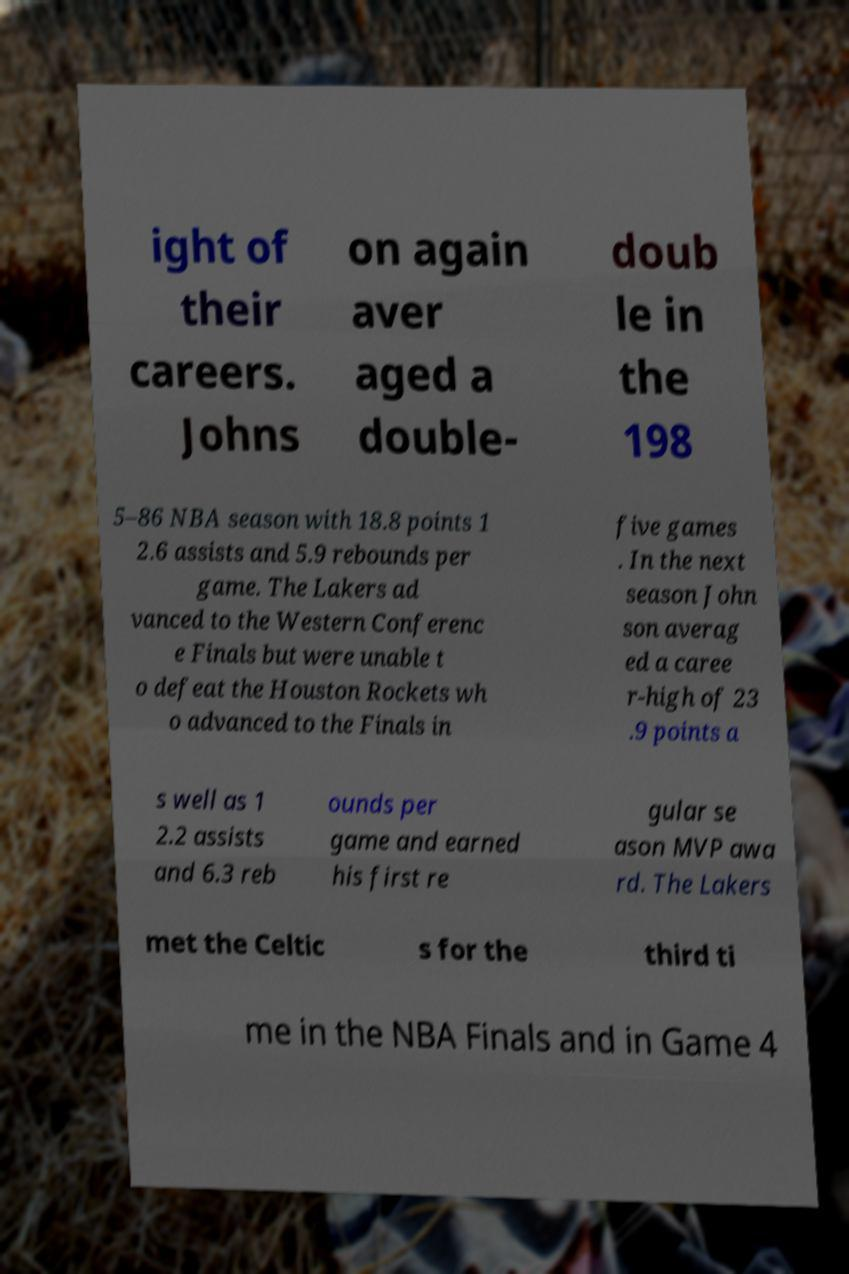For documentation purposes, I need the text within this image transcribed. Could you provide that? ight of their careers. Johns on again aver aged a double- doub le in the 198 5–86 NBA season with 18.8 points 1 2.6 assists and 5.9 rebounds per game. The Lakers ad vanced to the Western Conferenc e Finals but were unable t o defeat the Houston Rockets wh o advanced to the Finals in five games . In the next season John son averag ed a caree r-high of 23 .9 points a s well as 1 2.2 assists and 6.3 reb ounds per game and earned his first re gular se ason MVP awa rd. The Lakers met the Celtic s for the third ti me in the NBA Finals and in Game 4 